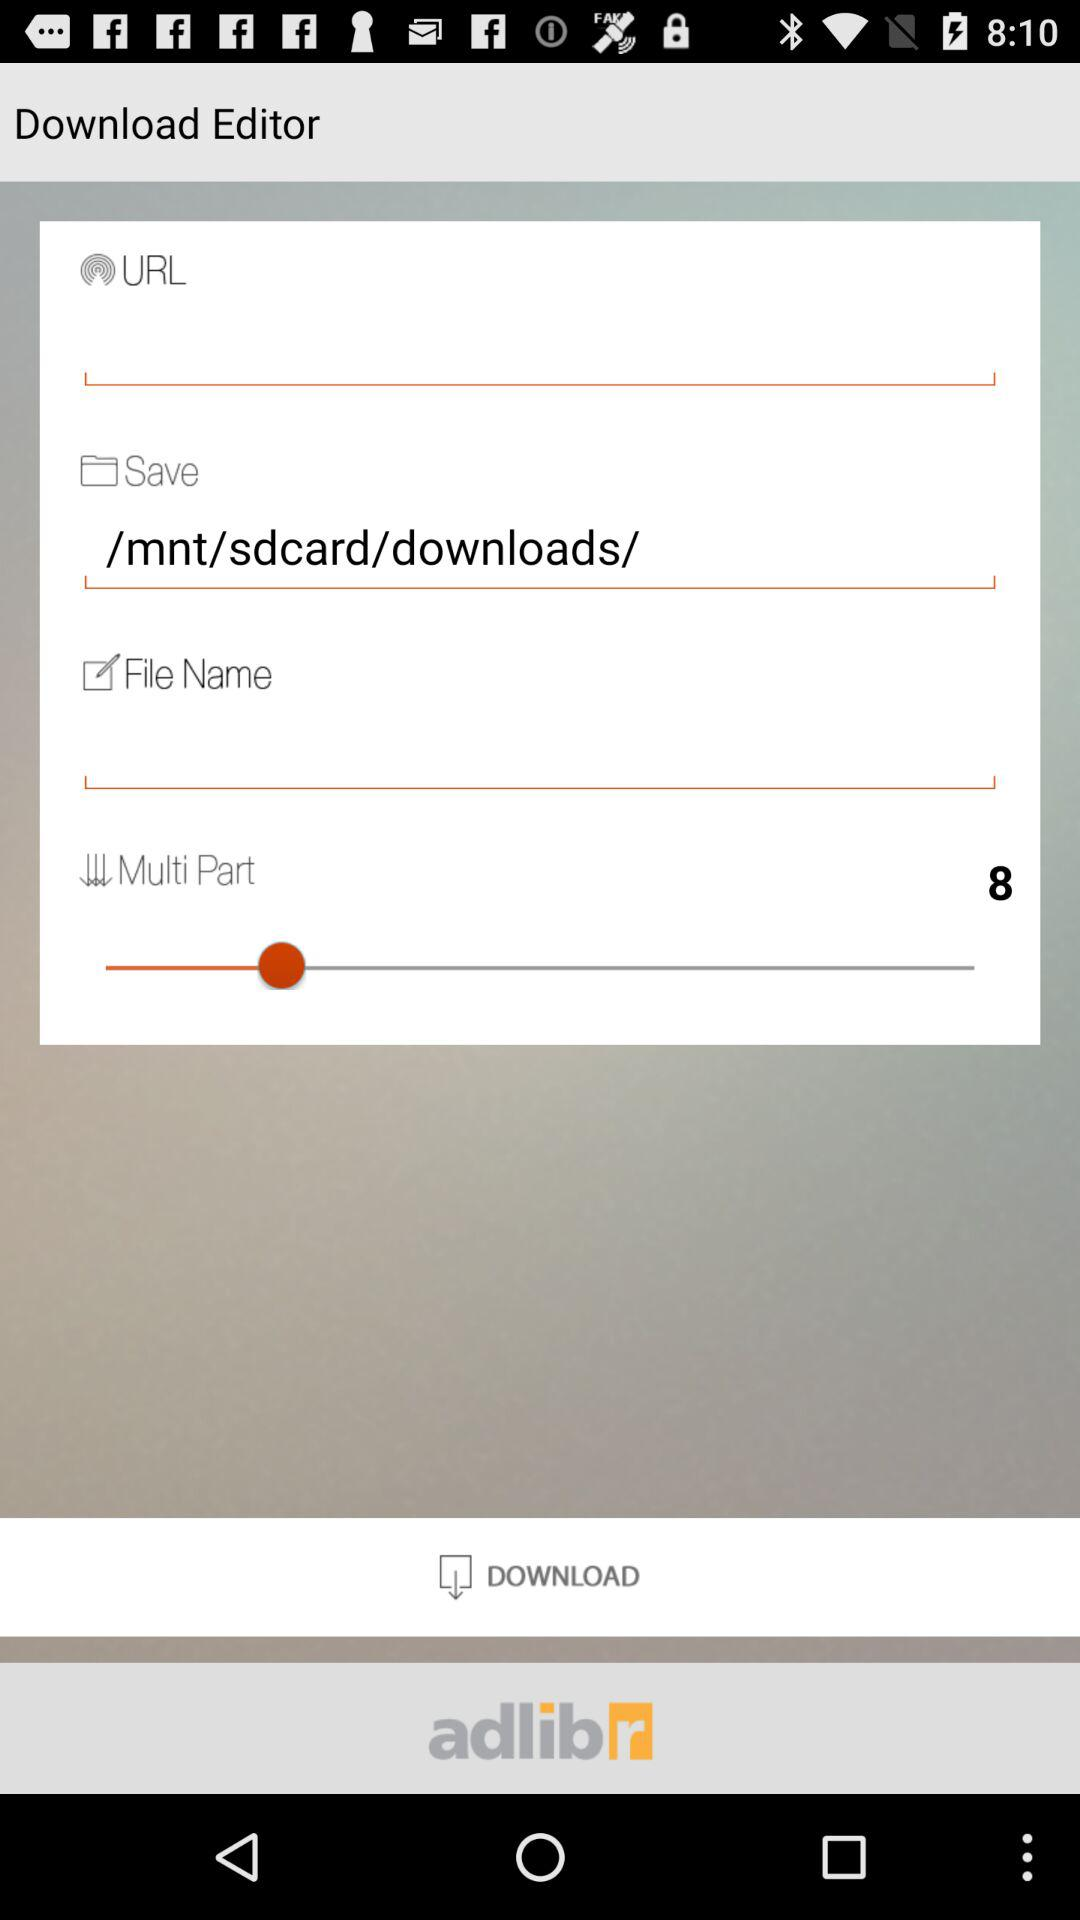How many text inputs are not empty in the Download Editor interface?
Answer the question using a single word or phrase. 2 